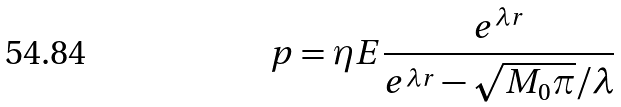<formula> <loc_0><loc_0><loc_500><loc_500>p = \eta E \frac { e ^ { \lambda r } } { e ^ { \lambda r } - \sqrt { M _ { 0 } \pi } / \lambda }</formula> 